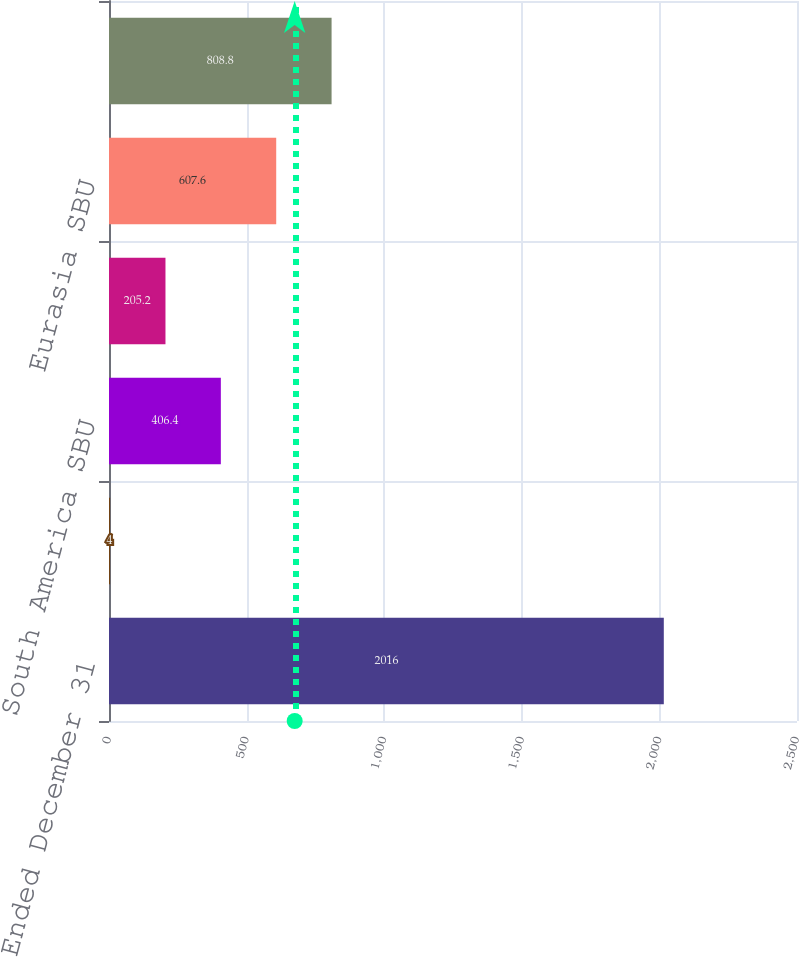Convert chart. <chart><loc_0><loc_0><loc_500><loc_500><bar_chart><fcel>Year Ended December 31<fcel>US and Utilities SBU<fcel>South America SBU<fcel>MCAC SBU<fcel>Eurasia SBU<fcel>Total<nl><fcel>2016<fcel>4<fcel>406.4<fcel>205.2<fcel>607.6<fcel>808.8<nl></chart> 